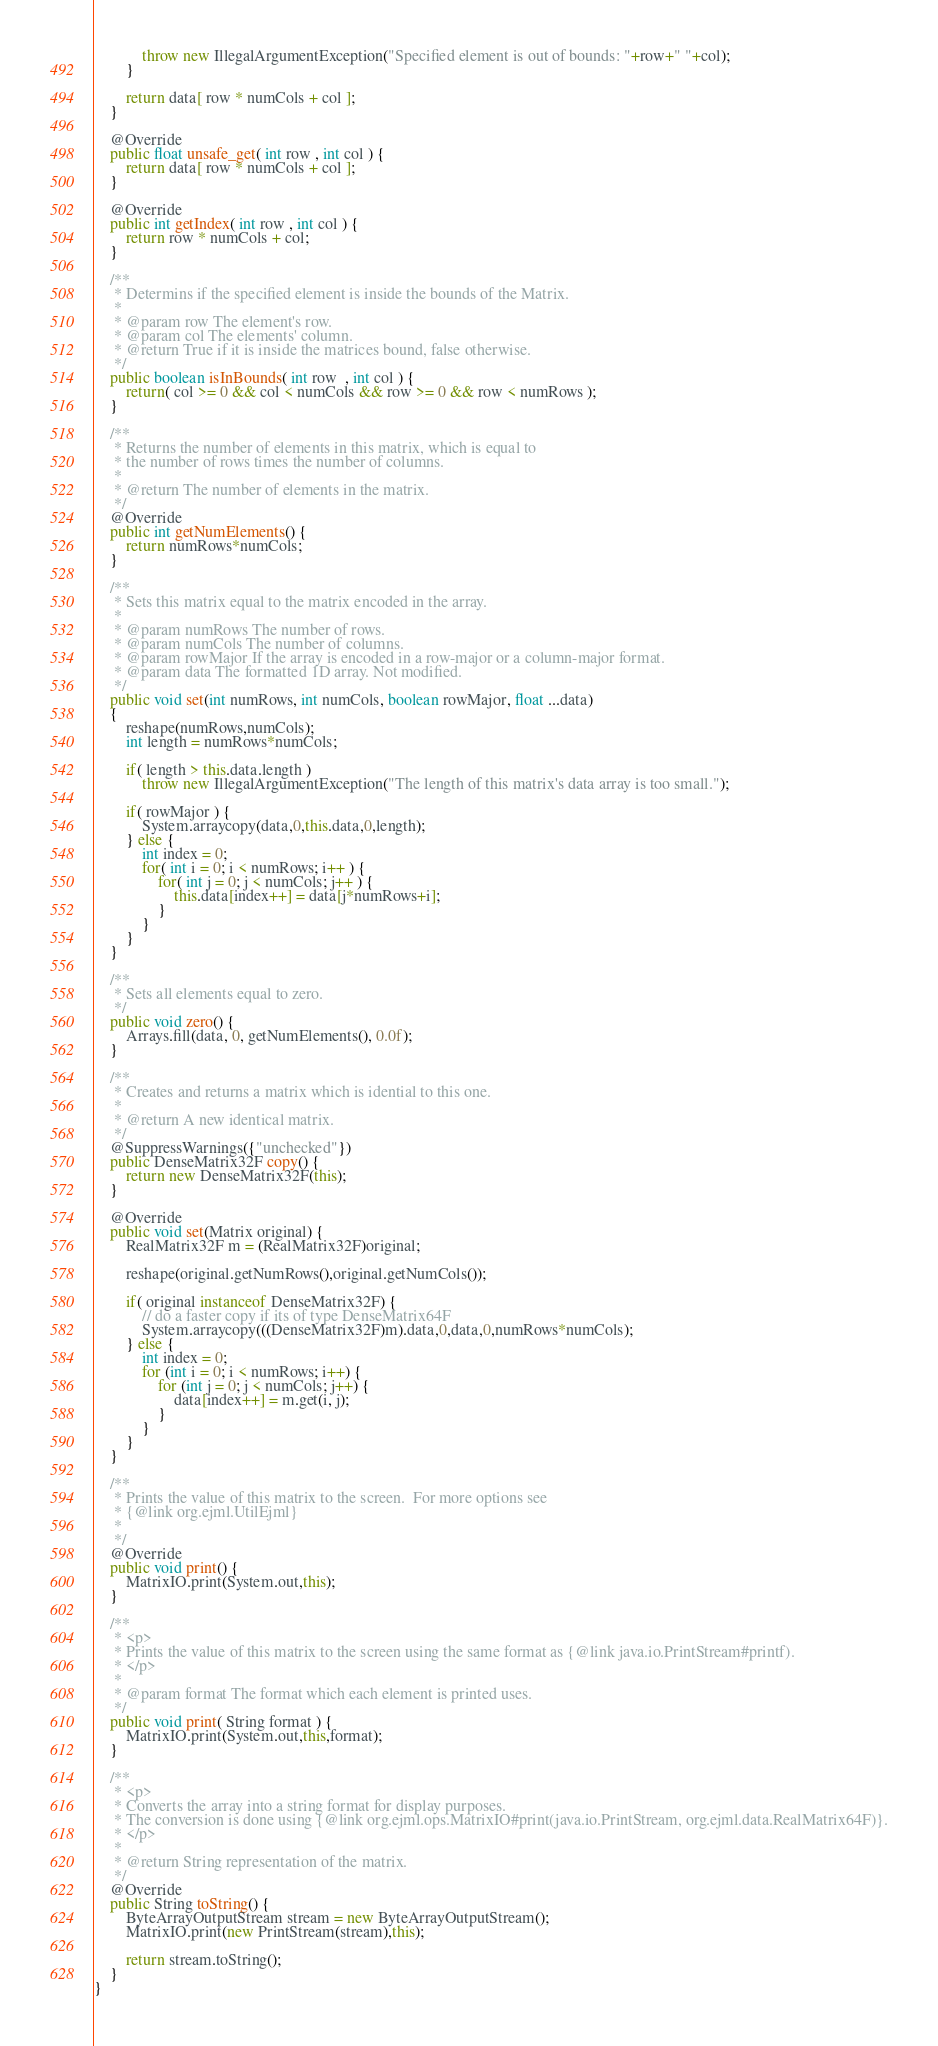<code> <loc_0><loc_0><loc_500><loc_500><_Java_>            throw new IllegalArgumentException("Specified element is out of bounds: "+row+" "+col);
        }

        return data[ row * numCols + col ];
    }

    @Override
    public float unsafe_get( int row , int col ) {
        return data[ row * numCols + col ];
    }

    @Override
    public int getIndex( int row , int col ) {
        return row * numCols + col;
    }

    /**
     * Determins if the specified element is inside the bounds of the Matrix.
     *
     * @param row The element's row.
     * @param col The elements' column.
     * @return True if it is inside the matrices bound, false otherwise.
     */
    public boolean isInBounds( int row  , int col ) {
        return( col >= 0 && col < numCols && row >= 0 && row < numRows );
    }

    /**
     * Returns the number of elements in this matrix, which is equal to
     * the number of rows times the number of columns.
     *
     * @return The number of elements in the matrix.
     */
    @Override
    public int getNumElements() {
        return numRows*numCols;
    }

    /**
     * Sets this matrix equal to the matrix encoded in the array.
     *
     * @param numRows The number of rows.
     * @param numCols The number of columns.
     * @param rowMajor If the array is encoded in a row-major or a column-major format.
     * @param data The formatted 1D array. Not modified.
     */
    public void set(int numRows, int numCols, boolean rowMajor, float ...data)
    {
        reshape(numRows,numCols);
        int length = numRows*numCols;

        if( length > this.data.length )
            throw new IllegalArgumentException("The length of this matrix's data array is too small.");

        if( rowMajor ) {
            System.arraycopy(data,0,this.data,0,length);
        } else {
            int index = 0;
            for( int i = 0; i < numRows; i++ ) {
                for( int j = 0; j < numCols; j++ ) {
                    this.data[index++] = data[j*numRows+i];
                }
            }
        }
    }

    /**
     * Sets all elements equal to zero.
     */
    public void zero() {
        Arrays.fill(data, 0, getNumElements(), 0.0f);
    }

    /**
     * Creates and returns a matrix which is idential to this one.
     *
     * @return A new identical matrix.
     */
    @SuppressWarnings({"unchecked"})
    public DenseMatrix32F copy() {
        return new DenseMatrix32F(this);
    }

    @Override
    public void set(Matrix original) {
        RealMatrix32F m = (RealMatrix32F)original;

        reshape(original.getNumRows(),original.getNumCols());

        if( original instanceof DenseMatrix32F) {
            // do a faster copy if its of type DenseMatrix64F
            System.arraycopy(((DenseMatrix32F)m).data,0,data,0,numRows*numCols);
        } else {
            int index = 0;
            for (int i = 0; i < numRows; i++) {
                for (int j = 0; j < numCols; j++) {
                    data[index++] = m.get(i, j);
                }
            }
        }
    }

    /**
     * Prints the value of this matrix to the screen.  For more options see
     * {@link org.ejml.UtilEjml}
     *
     */
    @Override
    public void print() {
        MatrixIO.print(System.out,this);
    }

    /**
     * <p>
     * Prints the value of this matrix to the screen using the same format as {@link java.io.PrintStream#printf).
     * </p>
     *
     * @param format The format which each element is printed uses.
     */
    public void print( String format ) {
        MatrixIO.print(System.out,this,format);
    }

    /**
     * <p>
     * Converts the array into a string format for display purposes.
     * The conversion is done using {@link org.ejml.ops.MatrixIO#print(java.io.PrintStream, org.ejml.data.RealMatrix64F)}.
     * </p>
     *
     * @return String representation of the matrix.
     */
    @Override
    public String toString() {
        ByteArrayOutputStream stream = new ByteArrayOutputStream();
        MatrixIO.print(new PrintStream(stream),this);

        return stream.toString();
    }
}
</code> 